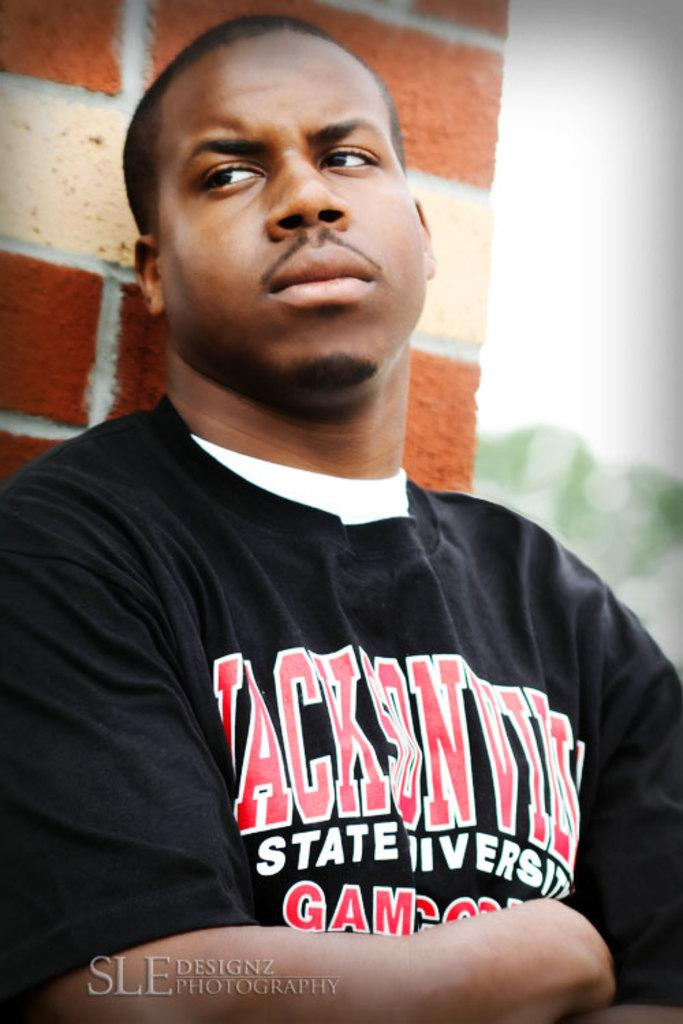<image>
Provide a brief description of the given image. A man in a black tshirt that says Jacksonville State University on it 